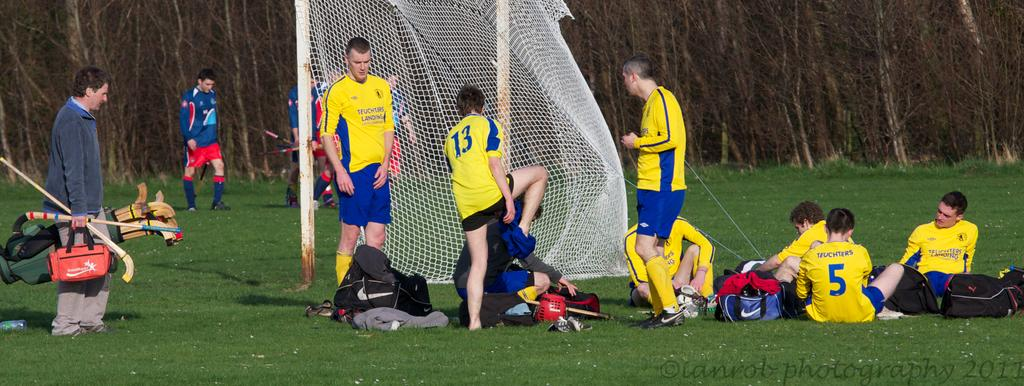<image>
Write a terse but informative summary of the picture. field hockey players resting on a field in blue and yellow jerseys with numbers such as 5 and 13 